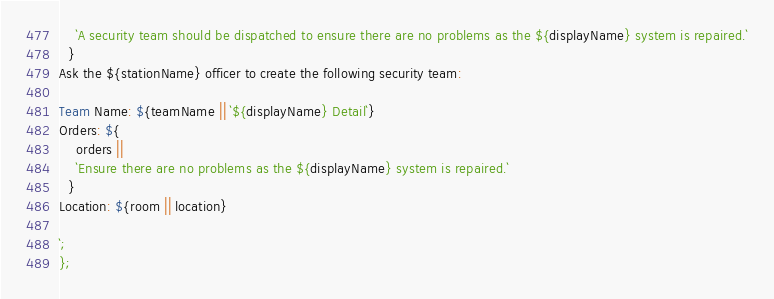Convert code to text. <code><loc_0><loc_0><loc_500><loc_500><_TypeScript_>    `A security team should be dispatched to ensure there are no problems as the ${displayName} system is repaired.`
  }
Ask the ${stationName} officer to create the following security team:

Team Name: ${teamName || `${displayName} Detail`}
Orders: ${
    orders ||
    `Ensure there are no problems as the ${displayName} system is repaired.`
  }
Location: ${room || location}

`;
};
</code> 